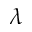Convert formula to latex. <formula><loc_0><loc_0><loc_500><loc_500>\lambda</formula> 